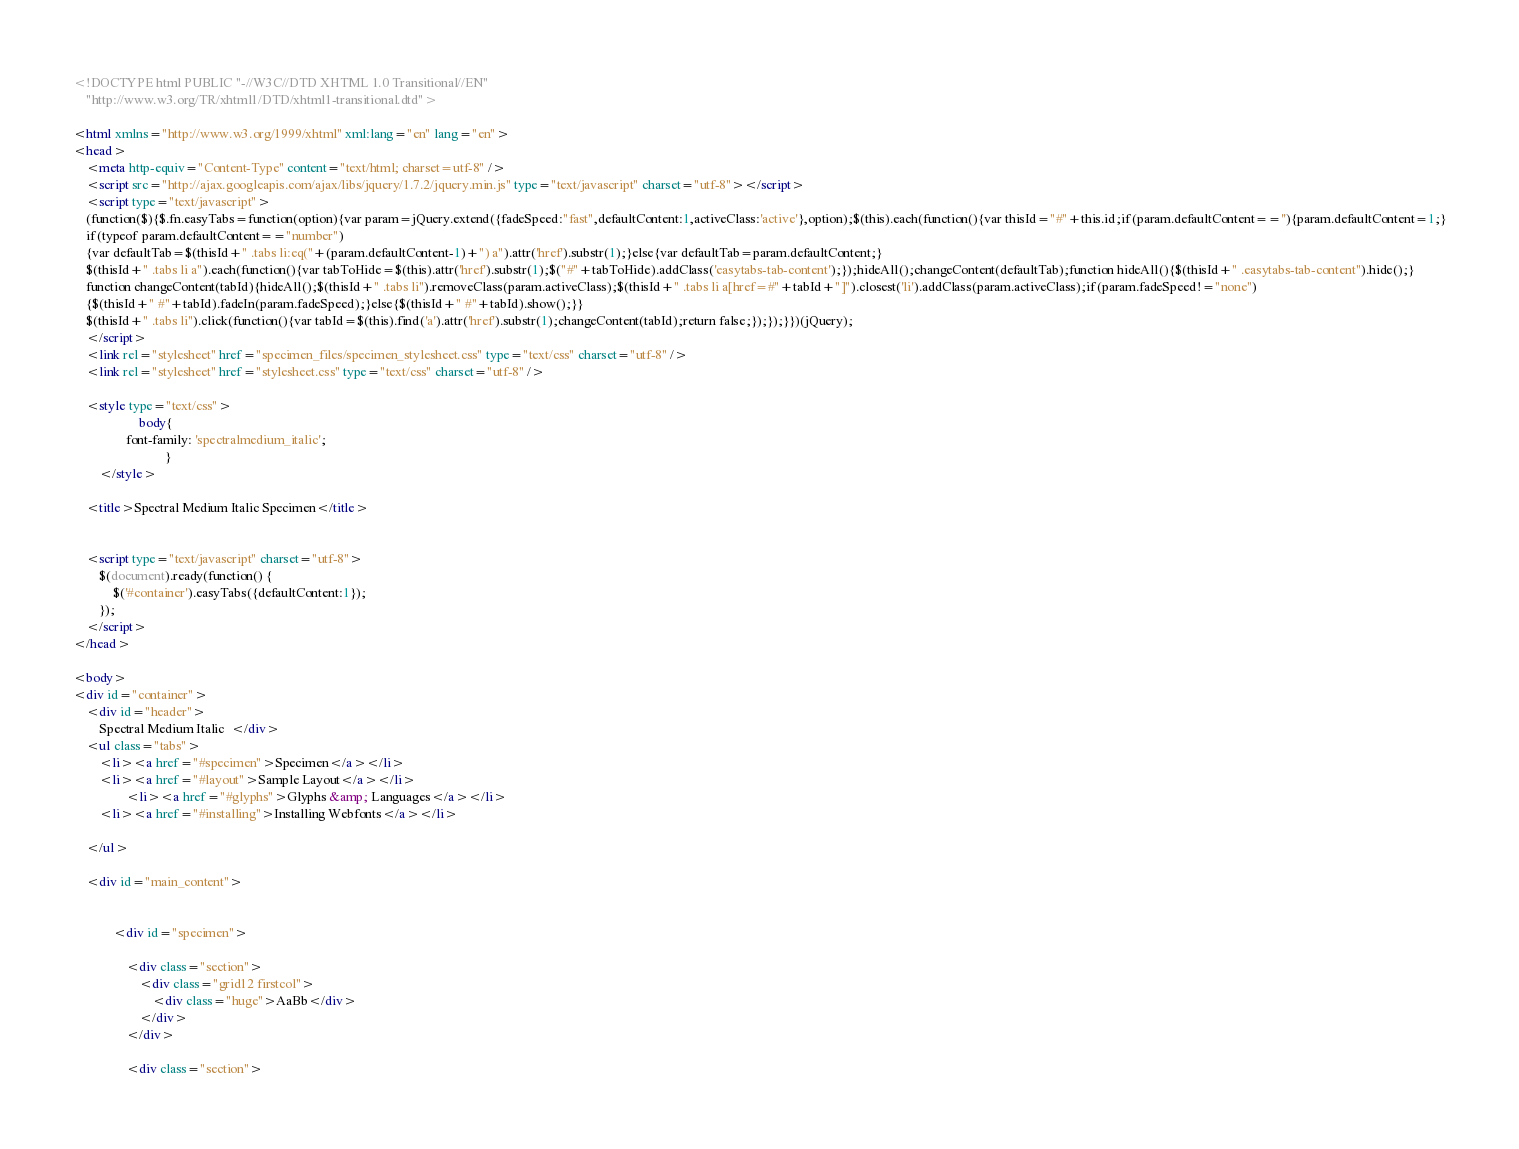<code> <loc_0><loc_0><loc_500><loc_500><_HTML_><!DOCTYPE html PUBLIC "-//W3C//DTD XHTML 1.0 Transitional//EN"
	"http://www.w3.org/TR/xhtml1/DTD/xhtml1-transitional.dtd">

<html xmlns="http://www.w3.org/1999/xhtml" xml:lang="en" lang="en">
<head>
	<meta http-equiv="Content-Type" content="text/html; charset=utf-8" />
	<script src="http://ajax.googleapis.com/ajax/libs/jquery/1.7.2/jquery.min.js" type="text/javascript" charset="utf-8"></script>
	<script type="text/javascript">
	(function($){$.fn.easyTabs=function(option){var param=jQuery.extend({fadeSpeed:"fast",defaultContent:1,activeClass:'active'},option);$(this).each(function(){var thisId="#"+this.id;if(param.defaultContent==''){param.defaultContent=1;}
	if(typeof param.defaultContent=="number")
	{var defaultTab=$(thisId+" .tabs li:eq("+(param.defaultContent-1)+") a").attr('href').substr(1);}else{var defaultTab=param.defaultContent;}
	$(thisId+" .tabs li a").each(function(){var tabToHide=$(this).attr('href').substr(1);$("#"+tabToHide).addClass('easytabs-tab-content');});hideAll();changeContent(defaultTab);function hideAll(){$(thisId+" .easytabs-tab-content").hide();}
	function changeContent(tabId){hideAll();$(thisId+" .tabs li").removeClass(param.activeClass);$(thisId+" .tabs li a[href=#"+tabId+"]").closest('li').addClass(param.activeClass);if(param.fadeSpeed!="none")
	{$(thisId+" #"+tabId).fadeIn(param.fadeSpeed);}else{$(thisId+" #"+tabId).show();}}
	$(thisId+" .tabs li").click(function(){var tabId=$(this).find('a').attr('href').substr(1);changeContent(tabId);return false;});});}})(jQuery);
	</script>
	<link rel="stylesheet" href="specimen_files/specimen_stylesheet.css" type="text/css" charset="utf-8" />
	<link rel="stylesheet" href="stylesheet.css" type="text/css" charset="utf-8" />

	<style type="text/css">
					body{
				font-family: 'spectralmedium_italic';
							}
		</style>

	<title>Spectral Medium Italic Specimen</title>
	
	
	<script type="text/javascript" charset="utf-8">
		$(document).ready(function() {
			$('#container').easyTabs({defaultContent:1});
		});
	</script>
</head>

<body>
<div id="container">
	<div id="header">
		Spectral Medium Italic	</div>
	<ul class="tabs">
		<li><a href="#specimen">Specimen</a></li>
		<li><a href="#layout">Sample Layout</a></li>
				<li><a href="#glyphs">Glyphs &amp; Languages</a></li>
		<li><a href="#installing">Installing Webfonts</a></li>
		
	</ul>
	
	<div id="main_content">

		
			<div id="specimen">
		
				<div class="section">
					<div class="grid12 firstcol">
						<div class="huge">AaBb</div>
					</div>
				</div>
		
				<div class="section"></code> 